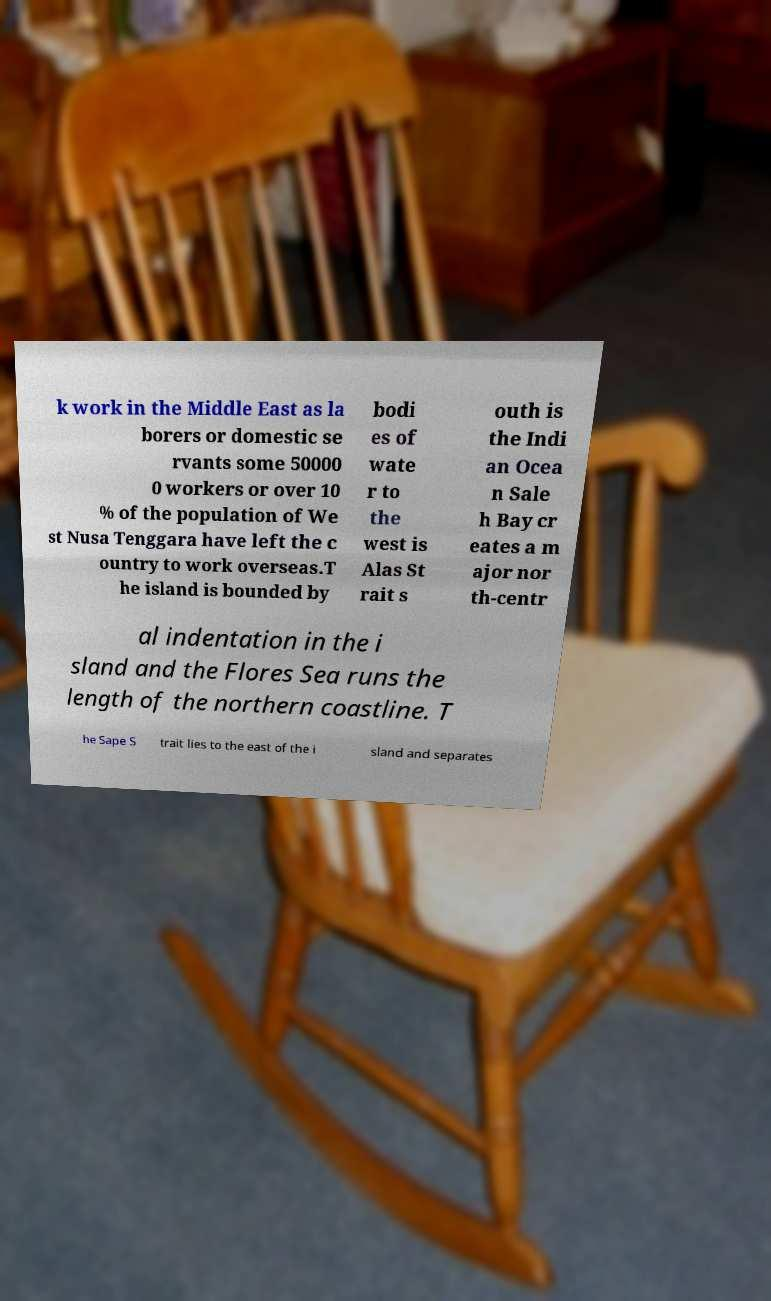There's text embedded in this image that I need extracted. Can you transcribe it verbatim? k work in the Middle East as la borers or domestic se rvants some 50000 0 workers or over 10 % of the population of We st Nusa Tenggara have left the c ountry to work overseas.T he island is bounded by bodi es of wate r to the west is Alas St rait s outh is the Indi an Ocea n Sale h Bay cr eates a m ajor nor th-centr al indentation in the i sland and the Flores Sea runs the length of the northern coastline. T he Sape S trait lies to the east of the i sland and separates 